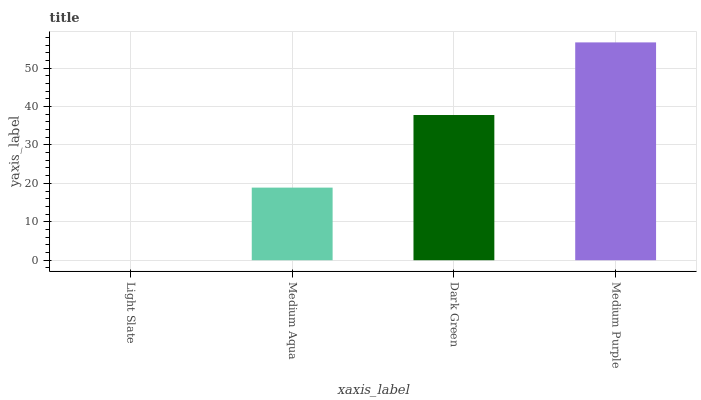Is Medium Aqua the minimum?
Answer yes or no. No. Is Medium Aqua the maximum?
Answer yes or no. No. Is Medium Aqua greater than Light Slate?
Answer yes or no. Yes. Is Light Slate less than Medium Aqua?
Answer yes or no. Yes. Is Light Slate greater than Medium Aqua?
Answer yes or no. No. Is Medium Aqua less than Light Slate?
Answer yes or no. No. Is Dark Green the high median?
Answer yes or no. Yes. Is Medium Aqua the low median?
Answer yes or no. Yes. Is Medium Purple the high median?
Answer yes or no. No. Is Dark Green the low median?
Answer yes or no. No. 